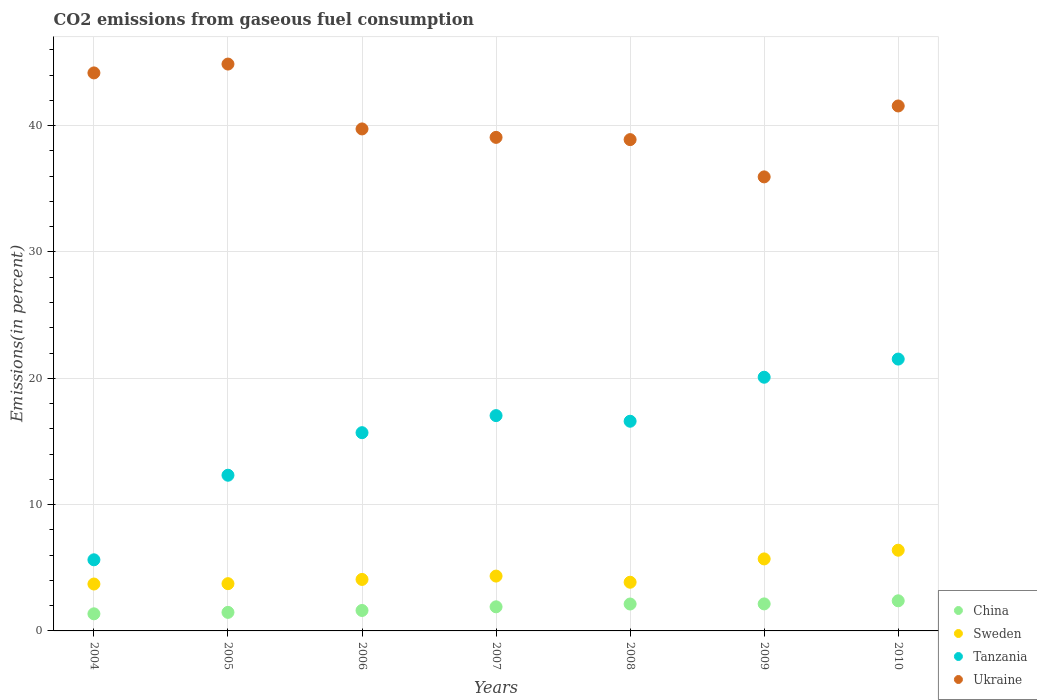Is the number of dotlines equal to the number of legend labels?
Offer a terse response. Yes. What is the total CO2 emitted in Tanzania in 2008?
Your response must be concise. 16.6. Across all years, what is the maximum total CO2 emitted in Tanzania?
Your response must be concise. 21.52. Across all years, what is the minimum total CO2 emitted in Ukraine?
Keep it short and to the point. 35.94. In which year was the total CO2 emitted in Tanzania minimum?
Your response must be concise. 2004. What is the total total CO2 emitted in Tanzania in the graph?
Keep it short and to the point. 108.9. What is the difference between the total CO2 emitted in Tanzania in 2004 and that in 2008?
Your response must be concise. -10.97. What is the difference between the total CO2 emitted in Sweden in 2005 and the total CO2 emitted in Tanzania in 2009?
Offer a very short reply. -16.34. What is the average total CO2 emitted in Sweden per year?
Keep it short and to the point. 4.54. In the year 2007, what is the difference between the total CO2 emitted in Tanzania and total CO2 emitted in China?
Your answer should be very brief. 15.14. What is the ratio of the total CO2 emitted in Tanzania in 2006 to that in 2009?
Give a very brief answer. 0.78. Is the total CO2 emitted in Sweden in 2005 less than that in 2010?
Your response must be concise. Yes. Is the difference between the total CO2 emitted in Tanzania in 2007 and 2010 greater than the difference between the total CO2 emitted in China in 2007 and 2010?
Give a very brief answer. No. What is the difference between the highest and the second highest total CO2 emitted in Ukraine?
Your answer should be very brief. 0.7. What is the difference between the highest and the lowest total CO2 emitted in Tanzania?
Make the answer very short. 15.89. Is it the case that in every year, the sum of the total CO2 emitted in Ukraine and total CO2 emitted in Sweden  is greater than the sum of total CO2 emitted in Tanzania and total CO2 emitted in China?
Offer a very short reply. Yes. Is the total CO2 emitted in Sweden strictly greater than the total CO2 emitted in China over the years?
Keep it short and to the point. Yes. How many dotlines are there?
Your answer should be compact. 4. Are the values on the major ticks of Y-axis written in scientific E-notation?
Ensure brevity in your answer.  No. Does the graph contain any zero values?
Offer a very short reply. No. Where does the legend appear in the graph?
Your answer should be compact. Bottom right. What is the title of the graph?
Your answer should be very brief. CO2 emissions from gaseous fuel consumption. What is the label or title of the Y-axis?
Ensure brevity in your answer.  Emissions(in percent). What is the Emissions(in percent) in China in 2004?
Offer a terse response. 1.35. What is the Emissions(in percent) of Sweden in 2004?
Your answer should be very brief. 3.71. What is the Emissions(in percent) of Tanzania in 2004?
Your answer should be very brief. 5.63. What is the Emissions(in percent) of Ukraine in 2004?
Keep it short and to the point. 44.17. What is the Emissions(in percent) in China in 2005?
Offer a terse response. 1.47. What is the Emissions(in percent) in Sweden in 2005?
Your answer should be very brief. 3.74. What is the Emissions(in percent) in Tanzania in 2005?
Make the answer very short. 12.33. What is the Emissions(in percent) in Ukraine in 2005?
Offer a very short reply. 44.87. What is the Emissions(in percent) in China in 2006?
Your answer should be very brief. 1.62. What is the Emissions(in percent) in Sweden in 2006?
Ensure brevity in your answer.  4.08. What is the Emissions(in percent) of Tanzania in 2006?
Keep it short and to the point. 15.69. What is the Emissions(in percent) in Ukraine in 2006?
Offer a terse response. 39.74. What is the Emissions(in percent) in China in 2007?
Ensure brevity in your answer.  1.91. What is the Emissions(in percent) of Sweden in 2007?
Ensure brevity in your answer.  4.34. What is the Emissions(in percent) in Tanzania in 2007?
Your response must be concise. 17.04. What is the Emissions(in percent) in Ukraine in 2007?
Provide a short and direct response. 39.07. What is the Emissions(in percent) in China in 2008?
Your response must be concise. 2.13. What is the Emissions(in percent) in Sweden in 2008?
Give a very brief answer. 3.85. What is the Emissions(in percent) in Tanzania in 2008?
Provide a short and direct response. 16.6. What is the Emissions(in percent) in Ukraine in 2008?
Provide a short and direct response. 38.89. What is the Emissions(in percent) of China in 2009?
Offer a very short reply. 2.14. What is the Emissions(in percent) of Sweden in 2009?
Your answer should be very brief. 5.7. What is the Emissions(in percent) of Tanzania in 2009?
Make the answer very short. 20.08. What is the Emissions(in percent) of Ukraine in 2009?
Your answer should be very brief. 35.94. What is the Emissions(in percent) of China in 2010?
Keep it short and to the point. 2.38. What is the Emissions(in percent) in Sweden in 2010?
Keep it short and to the point. 6.39. What is the Emissions(in percent) in Tanzania in 2010?
Give a very brief answer. 21.52. What is the Emissions(in percent) of Ukraine in 2010?
Offer a very short reply. 41.56. Across all years, what is the maximum Emissions(in percent) of China?
Give a very brief answer. 2.38. Across all years, what is the maximum Emissions(in percent) of Sweden?
Your answer should be very brief. 6.39. Across all years, what is the maximum Emissions(in percent) of Tanzania?
Provide a short and direct response. 21.52. Across all years, what is the maximum Emissions(in percent) of Ukraine?
Make the answer very short. 44.87. Across all years, what is the minimum Emissions(in percent) of China?
Your answer should be very brief. 1.35. Across all years, what is the minimum Emissions(in percent) in Sweden?
Your answer should be compact. 3.71. Across all years, what is the minimum Emissions(in percent) of Tanzania?
Provide a succinct answer. 5.63. Across all years, what is the minimum Emissions(in percent) of Ukraine?
Your answer should be compact. 35.94. What is the total Emissions(in percent) in China in the graph?
Offer a very short reply. 13. What is the total Emissions(in percent) of Sweden in the graph?
Your answer should be compact. 31.81. What is the total Emissions(in percent) of Tanzania in the graph?
Offer a very short reply. 108.9. What is the total Emissions(in percent) of Ukraine in the graph?
Give a very brief answer. 284.25. What is the difference between the Emissions(in percent) in China in 2004 and that in 2005?
Your answer should be compact. -0.11. What is the difference between the Emissions(in percent) in Sweden in 2004 and that in 2005?
Ensure brevity in your answer.  -0.03. What is the difference between the Emissions(in percent) in Tanzania in 2004 and that in 2005?
Keep it short and to the point. -6.69. What is the difference between the Emissions(in percent) in Ukraine in 2004 and that in 2005?
Keep it short and to the point. -0.7. What is the difference between the Emissions(in percent) of China in 2004 and that in 2006?
Your answer should be very brief. -0.27. What is the difference between the Emissions(in percent) in Sweden in 2004 and that in 2006?
Ensure brevity in your answer.  -0.36. What is the difference between the Emissions(in percent) in Tanzania in 2004 and that in 2006?
Make the answer very short. -10.06. What is the difference between the Emissions(in percent) of Ukraine in 2004 and that in 2006?
Your response must be concise. 4.43. What is the difference between the Emissions(in percent) of China in 2004 and that in 2007?
Give a very brief answer. -0.55. What is the difference between the Emissions(in percent) in Sweden in 2004 and that in 2007?
Your answer should be very brief. -0.63. What is the difference between the Emissions(in percent) in Tanzania in 2004 and that in 2007?
Offer a terse response. -11.41. What is the difference between the Emissions(in percent) of Ukraine in 2004 and that in 2007?
Offer a very short reply. 5.1. What is the difference between the Emissions(in percent) of China in 2004 and that in 2008?
Keep it short and to the point. -0.78. What is the difference between the Emissions(in percent) in Sweden in 2004 and that in 2008?
Your answer should be compact. -0.14. What is the difference between the Emissions(in percent) of Tanzania in 2004 and that in 2008?
Provide a short and direct response. -10.97. What is the difference between the Emissions(in percent) of Ukraine in 2004 and that in 2008?
Offer a terse response. 5.28. What is the difference between the Emissions(in percent) of China in 2004 and that in 2009?
Provide a succinct answer. -0.79. What is the difference between the Emissions(in percent) in Sweden in 2004 and that in 2009?
Ensure brevity in your answer.  -1.99. What is the difference between the Emissions(in percent) in Tanzania in 2004 and that in 2009?
Offer a terse response. -14.45. What is the difference between the Emissions(in percent) of Ukraine in 2004 and that in 2009?
Make the answer very short. 8.23. What is the difference between the Emissions(in percent) of China in 2004 and that in 2010?
Offer a very short reply. -1.03. What is the difference between the Emissions(in percent) in Sweden in 2004 and that in 2010?
Give a very brief answer. -2.68. What is the difference between the Emissions(in percent) in Tanzania in 2004 and that in 2010?
Make the answer very short. -15.89. What is the difference between the Emissions(in percent) in Ukraine in 2004 and that in 2010?
Your response must be concise. 2.62. What is the difference between the Emissions(in percent) in China in 2005 and that in 2006?
Keep it short and to the point. -0.15. What is the difference between the Emissions(in percent) in Sweden in 2005 and that in 2006?
Give a very brief answer. -0.34. What is the difference between the Emissions(in percent) in Tanzania in 2005 and that in 2006?
Offer a very short reply. -3.37. What is the difference between the Emissions(in percent) in Ukraine in 2005 and that in 2006?
Give a very brief answer. 5.14. What is the difference between the Emissions(in percent) of China in 2005 and that in 2007?
Give a very brief answer. -0.44. What is the difference between the Emissions(in percent) of Sweden in 2005 and that in 2007?
Offer a terse response. -0.6. What is the difference between the Emissions(in percent) in Tanzania in 2005 and that in 2007?
Provide a succinct answer. -4.72. What is the difference between the Emissions(in percent) in Ukraine in 2005 and that in 2007?
Offer a very short reply. 5.8. What is the difference between the Emissions(in percent) in China in 2005 and that in 2008?
Make the answer very short. -0.66. What is the difference between the Emissions(in percent) of Sweden in 2005 and that in 2008?
Give a very brief answer. -0.11. What is the difference between the Emissions(in percent) in Tanzania in 2005 and that in 2008?
Your answer should be compact. -4.27. What is the difference between the Emissions(in percent) of Ukraine in 2005 and that in 2008?
Keep it short and to the point. 5.98. What is the difference between the Emissions(in percent) of China in 2005 and that in 2009?
Make the answer very short. -0.67. What is the difference between the Emissions(in percent) in Sweden in 2005 and that in 2009?
Your response must be concise. -1.96. What is the difference between the Emissions(in percent) in Tanzania in 2005 and that in 2009?
Keep it short and to the point. -7.76. What is the difference between the Emissions(in percent) of Ukraine in 2005 and that in 2009?
Offer a terse response. 8.93. What is the difference between the Emissions(in percent) in China in 2005 and that in 2010?
Keep it short and to the point. -0.92. What is the difference between the Emissions(in percent) in Sweden in 2005 and that in 2010?
Your answer should be compact. -2.65. What is the difference between the Emissions(in percent) in Tanzania in 2005 and that in 2010?
Offer a terse response. -9.2. What is the difference between the Emissions(in percent) in Ukraine in 2005 and that in 2010?
Offer a very short reply. 3.32. What is the difference between the Emissions(in percent) of China in 2006 and that in 2007?
Ensure brevity in your answer.  -0.29. What is the difference between the Emissions(in percent) in Sweden in 2006 and that in 2007?
Give a very brief answer. -0.27. What is the difference between the Emissions(in percent) of Tanzania in 2006 and that in 2007?
Give a very brief answer. -1.35. What is the difference between the Emissions(in percent) in Ukraine in 2006 and that in 2007?
Offer a very short reply. 0.67. What is the difference between the Emissions(in percent) of China in 2006 and that in 2008?
Your answer should be compact. -0.51. What is the difference between the Emissions(in percent) in Sweden in 2006 and that in 2008?
Your answer should be compact. 0.22. What is the difference between the Emissions(in percent) of Tanzania in 2006 and that in 2008?
Your answer should be compact. -0.91. What is the difference between the Emissions(in percent) in Ukraine in 2006 and that in 2008?
Offer a very short reply. 0.85. What is the difference between the Emissions(in percent) of China in 2006 and that in 2009?
Provide a short and direct response. -0.52. What is the difference between the Emissions(in percent) of Sweden in 2006 and that in 2009?
Give a very brief answer. -1.62. What is the difference between the Emissions(in percent) of Tanzania in 2006 and that in 2009?
Your answer should be compact. -4.39. What is the difference between the Emissions(in percent) in Ukraine in 2006 and that in 2009?
Your response must be concise. 3.8. What is the difference between the Emissions(in percent) in China in 2006 and that in 2010?
Your answer should be compact. -0.77. What is the difference between the Emissions(in percent) in Sweden in 2006 and that in 2010?
Keep it short and to the point. -2.31. What is the difference between the Emissions(in percent) in Tanzania in 2006 and that in 2010?
Offer a terse response. -5.83. What is the difference between the Emissions(in percent) of Ukraine in 2006 and that in 2010?
Offer a terse response. -1.82. What is the difference between the Emissions(in percent) in China in 2007 and that in 2008?
Provide a short and direct response. -0.22. What is the difference between the Emissions(in percent) of Sweden in 2007 and that in 2008?
Provide a short and direct response. 0.49. What is the difference between the Emissions(in percent) in Tanzania in 2007 and that in 2008?
Offer a very short reply. 0.45. What is the difference between the Emissions(in percent) in Ukraine in 2007 and that in 2008?
Your answer should be compact. 0.18. What is the difference between the Emissions(in percent) of China in 2007 and that in 2009?
Offer a very short reply. -0.23. What is the difference between the Emissions(in percent) of Sweden in 2007 and that in 2009?
Give a very brief answer. -1.36. What is the difference between the Emissions(in percent) of Tanzania in 2007 and that in 2009?
Your answer should be compact. -3.04. What is the difference between the Emissions(in percent) in Ukraine in 2007 and that in 2009?
Offer a terse response. 3.13. What is the difference between the Emissions(in percent) in China in 2007 and that in 2010?
Your answer should be very brief. -0.48. What is the difference between the Emissions(in percent) of Sweden in 2007 and that in 2010?
Provide a succinct answer. -2.05. What is the difference between the Emissions(in percent) in Tanzania in 2007 and that in 2010?
Your answer should be very brief. -4.48. What is the difference between the Emissions(in percent) in Ukraine in 2007 and that in 2010?
Give a very brief answer. -2.49. What is the difference between the Emissions(in percent) in China in 2008 and that in 2009?
Provide a succinct answer. -0.01. What is the difference between the Emissions(in percent) in Sweden in 2008 and that in 2009?
Offer a very short reply. -1.85. What is the difference between the Emissions(in percent) of Tanzania in 2008 and that in 2009?
Make the answer very short. -3.48. What is the difference between the Emissions(in percent) in Ukraine in 2008 and that in 2009?
Give a very brief answer. 2.95. What is the difference between the Emissions(in percent) in China in 2008 and that in 2010?
Keep it short and to the point. -0.25. What is the difference between the Emissions(in percent) of Sweden in 2008 and that in 2010?
Your response must be concise. -2.54. What is the difference between the Emissions(in percent) in Tanzania in 2008 and that in 2010?
Offer a terse response. -4.92. What is the difference between the Emissions(in percent) in Ukraine in 2008 and that in 2010?
Your answer should be compact. -2.66. What is the difference between the Emissions(in percent) of China in 2009 and that in 2010?
Your answer should be very brief. -0.24. What is the difference between the Emissions(in percent) in Sweden in 2009 and that in 2010?
Ensure brevity in your answer.  -0.69. What is the difference between the Emissions(in percent) in Tanzania in 2009 and that in 2010?
Offer a very short reply. -1.44. What is the difference between the Emissions(in percent) in Ukraine in 2009 and that in 2010?
Your answer should be compact. -5.61. What is the difference between the Emissions(in percent) of China in 2004 and the Emissions(in percent) of Sweden in 2005?
Provide a succinct answer. -2.39. What is the difference between the Emissions(in percent) in China in 2004 and the Emissions(in percent) in Tanzania in 2005?
Provide a short and direct response. -10.97. What is the difference between the Emissions(in percent) in China in 2004 and the Emissions(in percent) in Ukraine in 2005?
Your answer should be compact. -43.52. What is the difference between the Emissions(in percent) in Sweden in 2004 and the Emissions(in percent) in Tanzania in 2005?
Your answer should be compact. -8.61. What is the difference between the Emissions(in percent) in Sweden in 2004 and the Emissions(in percent) in Ukraine in 2005?
Keep it short and to the point. -41.16. What is the difference between the Emissions(in percent) in Tanzania in 2004 and the Emissions(in percent) in Ukraine in 2005?
Your answer should be compact. -39.24. What is the difference between the Emissions(in percent) of China in 2004 and the Emissions(in percent) of Sweden in 2006?
Keep it short and to the point. -2.72. What is the difference between the Emissions(in percent) in China in 2004 and the Emissions(in percent) in Tanzania in 2006?
Ensure brevity in your answer.  -14.34. What is the difference between the Emissions(in percent) of China in 2004 and the Emissions(in percent) of Ukraine in 2006?
Provide a succinct answer. -38.39. What is the difference between the Emissions(in percent) in Sweden in 2004 and the Emissions(in percent) in Tanzania in 2006?
Make the answer very short. -11.98. What is the difference between the Emissions(in percent) in Sweden in 2004 and the Emissions(in percent) in Ukraine in 2006?
Your response must be concise. -36.03. What is the difference between the Emissions(in percent) in Tanzania in 2004 and the Emissions(in percent) in Ukraine in 2006?
Your answer should be very brief. -34.11. What is the difference between the Emissions(in percent) of China in 2004 and the Emissions(in percent) of Sweden in 2007?
Your response must be concise. -2.99. What is the difference between the Emissions(in percent) in China in 2004 and the Emissions(in percent) in Tanzania in 2007?
Offer a terse response. -15.69. What is the difference between the Emissions(in percent) in China in 2004 and the Emissions(in percent) in Ukraine in 2007?
Provide a short and direct response. -37.72. What is the difference between the Emissions(in percent) of Sweden in 2004 and the Emissions(in percent) of Tanzania in 2007?
Provide a succinct answer. -13.33. What is the difference between the Emissions(in percent) of Sweden in 2004 and the Emissions(in percent) of Ukraine in 2007?
Give a very brief answer. -35.36. What is the difference between the Emissions(in percent) in Tanzania in 2004 and the Emissions(in percent) in Ukraine in 2007?
Provide a succinct answer. -33.44. What is the difference between the Emissions(in percent) of China in 2004 and the Emissions(in percent) of Sweden in 2008?
Offer a very short reply. -2.5. What is the difference between the Emissions(in percent) of China in 2004 and the Emissions(in percent) of Tanzania in 2008?
Offer a terse response. -15.25. What is the difference between the Emissions(in percent) of China in 2004 and the Emissions(in percent) of Ukraine in 2008?
Your answer should be very brief. -37.54. What is the difference between the Emissions(in percent) in Sweden in 2004 and the Emissions(in percent) in Tanzania in 2008?
Offer a very short reply. -12.89. What is the difference between the Emissions(in percent) in Sweden in 2004 and the Emissions(in percent) in Ukraine in 2008?
Your response must be concise. -35.18. What is the difference between the Emissions(in percent) of Tanzania in 2004 and the Emissions(in percent) of Ukraine in 2008?
Your answer should be compact. -33.26. What is the difference between the Emissions(in percent) in China in 2004 and the Emissions(in percent) in Sweden in 2009?
Your response must be concise. -4.35. What is the difference between the Emissions(in percent) in China in 2004 and the Emissions(in percent) in Tanzania in 2009?
Offer a very short reply. -18.73. What is the difference between the Emissions(in percent) in China in 2004 and the Emissions(in percent) in Ukraine in 2009?
Your answer should be compact. -34.59. What is the difference between the Emissions(in percent) of Sweden in 2004 and the Emissions(in percent) of Tanzania in 2009?
Give a very brief answer. -16.37. What is the difference between the Emissions(in percent) in Sweden in 2004 and the Emissions(in percent) in Ukraine in 2009?
Offer a terse response. -32.23. What is the difference between the Emissions(in percent) in Tanzania in 2004 and the Emissions(in percent) in Ukraine in 2009?
Provide a short and direct response. -30.31. What is the difference between the Emissions(in percent) in China in 2004 and the Emissions(in percent) in Sweden in 2010?
Keep it short and to the point. -5.04. What is the difference between the Emissions(in percent) in China in 2004 and the Emissions(in percent) in Tanzania in 2010?
Offer a very short reply. -20.17. What is the difference between the Emissions(in percent) in China in 2004 and the Emissions(in percent) in Ukraine in 2010?
Keep it short and to the point. -40.2. What is the difference between the Emissions(in percent) of Sweden in 2004 and the Emissions(in percent) of Tanzania in 2010?
Keep it short and to the point. -17.81. What is the difference between the Emissions(in percent) in Sweden in 2004 and the Emissions(in percent) in Ukraine in 2010?
Your answer should be very brief. -37.84. What is the difference between the Emissions(in percent) in Tanzania in 2004 and the Emissions(in percent) in Ukraine in 2010?
Offer a very short reply. -35.93. What is the difference between the Emissions(in percent) in China in 2005 and the Emissions(in percent) in Sweden in 2006?
Ensure brevity in your answer.  -2.61. What is the difference between the Emissions(in percent) in China in 2005 and the Emissions(in percent) in Tanzania in 2006?
Offer a very short reply. -14.22. What is the difference between the Emissions(in percent) in China in 2005 and the Emissions(in percent) in Ukraine in 2006?
Provide a short and direct response. -38.27. What is the difference between the Emissions(in percent) of Sweden in 2005 and the Emissions(in percent) of Tanzania in 2006?
Your response must be concise. -11.95. What is the difference between the Emissions(in percent) of Sweden in 2005 and the Emissions(in percent) of Ukraine in 2006?
Ensure brevity in your answer.  -36. What is the difference between the Emissions(in percent) in Tanzania in 2005 and the Emissions(in percent) in Ukraine in 2006?
Provide a short and direct response. -27.41. What is the difference between the Emissions(in percent) in China in 2005 and the Emissions(in percent) in Sweden in 2007?
Your response must be concise. -2.87. What is the difference between the Emissions(in percent) of China in 2005 and the Emissions(in percent) of Tanzania in 2007?
Your response must be concise. -15.58. What is the difference between the Emissions(in percent) in China in 2005 and the Emissions(in percent) in Ukraine in 2007?
Your response must be concise. -37.6. What is the difference between the Emissions(in percent) of Sweden in 2005 and the Emissions(in percent) of Tanzania in 2007?
Offer a terse response. -13.3. What is the difference between the Emissions(in percent) of Sweden in 2005 and the Emissions(in percent) of Ukraine in 2007?
Your answer should be compact. -35.33. What is the difference between the Emissions(in percent) in Tanzania in 2005 and the Emissions(in percent) in Ukraine in 2007?
Give a very brief answer. -26.75. What is the difference between the Emissions(in percent) of China in 2005 and the Emissions(in percent) of Sweden in 2008?
Your answer should be compact. -2.38. What is the difference between the Emissions(in percent) in China in 2005 and the Emissions(in percent) in Tanzania in 2008?
Your answer should be very brief. -15.13. What is the difference between the Emissions(in percent) of China in 2005 and the Emissions(in percent) of Ukraine in 2008?
Keep it short and to the point. -37.42. What is the difference between the Emissions(in percent) of Sweden in 2005 and the Emissions(in percent) of Tanzania in 2008?
Provide a succinct answer. -12.86. What is the difference between the Emissions(in percent) of Sweden in 2005 and the Emissions(in percent) of Ukraine in 2008?
Offer a terse response. -35.15. What is the difference between the Emissions(in percent) in Tanzania in 2005 and the Emissions(in percent) in Ukraine in 2008?
Provide a short and direct response. -26.57. What is the difference between the Emissions(in percent) of China in 2005 and the Emissions(in percent) of Sweden in 2009?
Provide a succinct answer. -4.23. What is the difference between the Emissions(in percent) in China in 2005 and the Emissions(in percent) in Tanzania in 2009?
Provide a short and direct response. -18.61. What is the difference between the Emissions(in percent) in China in 2005 and the Emissions(in percent) in Ukraine in 2009?
Your answer should be very brief. -34.47. What is the difference between the Emissions(in percent) in Sweden in 2005 and the Emissions(in percent) in Tanzania in 2009?
Ensure brevity in your answer.  -16.34. What is the difference between the Emissions(in percent) of Sweden in 2005 and the Emissions(in percent) of Ukraine in 2009?
Your response must be concise. -32.2. What is the difference between the Emissions(in percent) in Tanzania in 2005 and the Emissions(in percent) in Ukraine in 2009?
Your answer should be very brief. -23.62. What is the difference between the Emissions(in percent) of China in 2005 and the Emissions(in percent) of Sweden in 2010?
Your response must be concise. -4.92. What is the difference between the Emissions(in percent) in China in 2005 and the Emissions(in percent) in Tanzania in 2010?
Offer a very short reply. -20.05. What is the difference between the Emissions(in percent) of China in 2005 and the Emissions(in percent) of Ukraine in 2010?
Offer a very short reply. -40.09. What is the difference between the Emissions(in percent) in Sweden in 2005 and the Emissions(in percent) in Tanzania in 2010?
Ensure brevity in your answer.  -17.78. What is the difference between the Emissions(in percent) in Sweden in 2005 and the Emissions(in percent) in Ukraine in 2010?
Offer a very short reply. -37.82. What is the difference between the Emissions(in percent) in Tanzania in 2005 and the Emissions(in percent) in Ukraine in 2010?
Offer a very short reply. -29.23. What is the difference between the Emissions(in percent) of China in 2006 and the Emissions(in percent) of Sweden in 2007?
Offer a very short reply. -2.72. What is the difference between the Emissions(in percent) in China in 2006 and the Emissions(in percent) in Tanzania in 2007?
Make the answer very short. -15.43. What is the difference between the Emissions(in percent) in China in 2006 and the Emissions(in percent) in Ukraine in 2007?
Offer a very short reply. -37.45. What is the difference between the Emissions(in percent) in Sweden in 2006 and the Emissions(in percent) in Tanzania in 2007?
Your answer should be compact. -12.97. What is the difference between the Emissions(in percent) in Sweden in 2006 and the Emissions(in percent) in Ukraine in 2007?
Make the answer very short. -35. What is the difference between the Emissions(in percent) of Tanzania in 2006 and the Emissions(in percent) of Ukraine in 2007?
Provide a succinct answer. -23.38. What is the difference between the Emissions(in percent) of China in 2006 and the Emissions(in percent) of Sweden in 2008?
Make the answer very short. -2.23. What is the difference between the Emissions(in percent) in China in 2006 and the Emissions(in percent) in Tanzania in 2008?
Provide a short and direct response. -14.98. What is the difference between the Emissions(in percent) of China in 2006 and the Emissions(in percent) of Ukraine in 2008?
Give a very brief answer. -37.27. What is the difference between the Emissions(in percent) of Sweden in 2006 and the Emissions(in percent) of Tanzania in 2008?
Your response must be concise. -12.52. What is the difference between the Emissions(in percent) of Sweden in 2006 and the Emissions(in percent) of Ukraine in 2008?
Keep it short and to the point. -34.82. What is the difference between the Emissions(in percent) in Tanzania in 2006 and the Emissions(in percent) in Ukraine in 2008?
Provide a short and direct response. -23.2. What is the difference between the Emissions(in percent) in China in 2006 and the Emissions(in percent) in Sweden in 2009?
Provide a short and direct response. -4.08. What is the difference between the Emissions(in percent) in China in 2006 and the Emissions(in percent) in Tanzania in 2009?
Provide a short and direct response. -18.46. What is the difference between the Emissions(in percent) in China in 2006 and the Emissions(in percent) in Ukraine in 2009?
Give a very brief answer. -34.32. What is the difference between the Emissions(in percent) in Sweden in 2006 and the Emissions(in percent) in Tanzania in 2009?
Provide a short and direct response. -16.01. What is the difference between the Emissions(in percent) of Sweden in 2006 and the Emissions(in percent) of Ukraine in 2009?
Your answer should be very brief. -31.87. What is the difference between the Emissions(in percent) of Tanzania in 2006 and the Emissions(in percent) of Ukraine in 2009?
Offer a terse response. -20.25. What is the difference between the Emissions(in percent) of China in 2006 and the Emissions(in percent) of Sweden in 2010?
Your answer should be compact. -4.77. What is the difference between the Emissions(in percent) of China in 2006 and the Emissions(in percent) of Tanzania in 2010?
Provide a succinct answer. -19.9. What is the difference between the Emissions(in percent) in China in 2006 and the Emissions(in percent) in Ukraine in 2010?
Provide a succinct answer. -39.94. What is the difference between the Emissions(in percent) of Sweden in 2006 and the Emissions(in percent) of Tanzania in 2010?
Provide a short and direct response. -17.44. What is the difference between the Emissions(in percent) of Sweden in 2006 and the Emissions(in percent) of Ukraine in 2010?
Offer a terse response. -37.48. What is the difference between the Emissions(in percent) in Tanzania in 2006 and the Emissions(in percent) in Ukraine in 2010?
Provide a succinct answer. -25.86. What is the difference between the Emissions(in percent) in China in 2007 and the Emissions(in percent) in Sweden in 2008?
Provide a succinct answer. -1.95. What is the difference between the Emissions(in percent) in China in 2007 and the Emissions(in percent) in Tanzania in 2008?
Keep it short and to the point. -14.69. What is the difference between the Emissions(in percent) in China in 2007 and the Emissions(in percent) in Ukraine in 2008?
Your answer should be compact. -36.99. What is the difference between the Emissions(in percent) of Sweden in 2007 and the Emissions(in percent) of Tanzania in 2008?
Offer a very short reply. -12.26. What is the difference between the Emissions(in percent) in Sweden in 2007 and the Emissions(in percent) in Ukraine in 2008?
Give a very brief answer. -34.55. What is the difference between the Emissions(in percent) of Tanzania in 2007 and the Emissions(in percent) of Ukraine in 2008?
Ensure brevity in your answer.  -21.85. What is the difference between the Emissions(in percent) of China in 2007 and the Emissions(in percent) of Sweden in 2009?
Keep it short and to the point. -3.79. What is the difference between the Emissions(in percent) of China in 2007 and the Emissions(in percent) of Tanzania in 2009?
Your answer should be very brief. -18.18. What is the difference between the Emissions(in percent) in China in 2007 and the Emissions(in percent) in Ukraine in 2009?
Ensure brevity in your answer.  -34.04. What is the difference between the Emissions(in percent) of Sweden in 2007 and the Emissions(in percent) of Tanzania in 2009?
Ensure brevity in your answer.  -15.74. What is the difference between the Emissions(in percent) of Sweden in 2007 and the Emissions(in percent) of Ukraine in 2009?
Your answer should be very brief. -31.6. What is the difference between the Emissions(in percent) in Tanzania in 2007 and the Emissions(in percent) in Ukraine in 2009?
Offer a very short reply. -18.9. What is the difference between the Emissions(in percent) of China in 2007 and the Emissions(in percent) of Sweden in 2010?
Give a very brief answer. -4.48. What is the difference between the Emissions(in percent) in China in 2007 and the Emissions(in percent) in Tanzania in 2010?
Make the answer very short. -19.61. What is the difference between the Emissions(in percent) of China in 2007 and the Emissions(in percent) of Ukraine in 2010?
Ensure brevity in your answer.  -39.65. What is the difference between the Emissions(in percent) in Sweden in 2007 and the Emissions(in percent) in Tanzania in 2010?
Your response must be concise. -17.18. What is the difference between the Emissions(in percent) in Sweden in 2007 and the Emissions(in percent) in Ukraine in 2010?
Provide a short and direct response. -37.22. What is the difference between the Emissions(in percent) of Tanzania in 2007 and the Emissions(in percent) of Ukraine in 2010?
Provide a succinct answer. -24.51. What is the difference between the Emissions(in percent) in China in 2008 and the Emissions(in percent) in Sweden in 2009?
Provide a short and direct response. -3.57. What is the difference between the Emissions(in percent) in China in 2008 and the Emissions(in percent) in Tanzania in 2009?
Ensure brevity in your answer.  -17.95. What is the difference between the Emissions(in percent) of China in 2008 and the Emissions(in percent) of Ukraine in 2009?
Your answer should be very brief. -33.81. What is the difference between the Emissions(in percent) in Sweden in 2008 and the Emissions(in percent) in Tanzania in 2009?
Make the answer very short. -16.23. What is the difference between the Emissions(in percent) of Sweden in 2008 and the Emissions(in percent) of Ukraine in 2009?
Make the answer very short. -32.09. What is the difference between the Emissions(in percent) in Tanzania in 2008 and the Emissions(in percent) in Ukraine in 2009?
Make the answer very short. -19.34. What is the difference between the Emissions(in percent) of China in 2008 and the Emissions(in percent) of Sweden in 2010?
Your answer should be compact. -4.26. What is the difference between the Emissions(in percent) of China in 2008 and the Emissions(in percent) of Tanzania in 2010?
Offer a terse response. -19.39. What is the difference between the Emissions(in percent) in China in 2008 and the Emissions(in percent) in Ukraine in 2010?
Make the answer very short. -39.43. What is the difference between the Emissions(in percent) in Sweden in 2008 and the Emissions(in percent) in Tanzania in 2010?
Keep it short and to the point. -17.67. What is the difference between the Emissions(in percent) in Sweden in 2008 and the Emissions(in percent) in Ukraine in 2010?
Provide a short and direct response. -37.7. What is the difference between the Emissions(in percent) of Tanzania in 2008 and the Emissions(in percent) of Ukraine in 2010?
Make the answer very short. -24.96. What is the difference between the Emissions(in percent) in China in 2009 and the Emissions(in percent) in Sweden in 2010?
Your answer should be very brief. -4.25. What is the difference between the Emissions(in percent) in China in 2009 and the Emissions(in percent) in Tanzania in 2010?
Offer a terse response. -19.38. What is the difference between the Emissions(in percent) in China in 2009 and the Emissions(in percent) in Ukraine in 2010?
Keep it short and to the point. -39.42. What is the difference between the Emissions(in percent) of Sweden in 2009 and the Emissions(in percent) of Tanzania in 2010?
Make the answer very short. -15.82. What is the difference between the Emissions(in percent) in Sweden in 2009 and the Emissions(in percent) in Ukraine in 2010?
Give a very brief answer. -35.86. What is the difference between the Emissions(in percent) in Tanzania in 2009 and the Emissions(in percent) in Ukraine in 2010?
Provide a short and direct response. -21.47. What is the average Emissions(in percent) of China per year?
Make the answer very short. 1.86. What is the average Emissions(in percent) of Sweden per year?
Your answer should be very brief. 4.54. What is the average Emissions(in percent) in Tanzania per year?
Make the answer very short. 15.56. What is the average Emissions(in percent) of Ukraine per year?
Your answer should be compact. 40.61. In the year 2004, what is the difference between the Emissions(in percent) in China and Emissions(in percent) in Sweden?
Give a very brief answer. -2.36. In the year 2004, what is the difference between the Emissions(in percent) of China and Emissions(in percent) of Tanzania?
Ensure brevity in your answer.  -4.28. In the year 2004, what is the difference between the Emissions(in percent) of China and Emissions(in percent) of Ukraine?
Make the answer very short. -42.82. In the year 2004, what is the difference between the Emissions(in percent) in Sweden and Emissions(in percent) in Tanzania?
Your answer should be very brief. -1.92. In the year 2004, what is the difference between the Emissions(in percent) in Sweden and Emissions(in percent) in Ukraine?
Provide a succinct answer. -40.46. In the year 2004, what is the difference between the Emissions(in percent) in Tanzania and Emissions(in percent) in Ukraine?
Your answer should be compact. -38.54. In the year 2005, what is the difference between the Emissions(in percent) in China and Emissions(in percent) in Sweden?
Your answer should be compact. -2.27. In the year 2005, what is the difference between the Emissions(in percent) in China and Emissions(in percent) in Tanzania?
Provide a short and direct response. -10.86. In the year 2005, what is the difference between the Emissions(in percent) of China and Emissions(in percent) of Ukraine?
Provide a short and direct response. -43.41. In the year 2005, what is the difference between the Emissions(in percent) of Sweden and Emissions(in percent) of Tanzania?
Give a very brief answer. -8.58. In the year 2005, what is the difference between the Emissions(in percent) of Sweden and Emissions(in percent) of Ukraine?
Provide a succinct answer. -41.13. In the year 2005, what is the difference between the Emissions(in percent) in Tanzania and Emissions(in percent) in Ukraine?
Make the answer very short. -32.55. In the year 2006, what is the difference between the Emissions(in percent) in China and Emissions(in percent) in Sweden?
Make the answer very short. -2.46. In the year 2006, what is the difference between the Emissions(in percent) of China and Emissions(in percent) of Tanzania?
Provide a short and direct response. -14.07. In the year 2006, what is the difference between the Emissions(in percent) in China and Emissions(in percent) in Ukraine?
Your answer should be compact. -38.12. In the year 2006, what is the difference between the Emissions(in percent) of Sweden and Emissions(in percent) of Tanzania?
Provide a succinct answer. -11.62. In the year 2006, what is the difference between the Emissions(in percent) in Sweden and Emissions(in percent) in Ukraine?
Keep it short and to the point. -35.66. In the year 2006, what is the difference between the Emissions(in percent) of Tanzania and Emissions(in percent) of Ukraine?
Your answer should be very brief. -24.05. In the year 2007, what is the difference between the Emissions(in percent) of China and Emissions(in percent) of Sweden?
Provide a short and direct response. -2.43. In the year 2007, what is the difference between the Emissions(in percent) in China and Emissions(in percent) in Tanzania?
Your answer should be very brief. -15.14. In the year 2007, what is the difference between the Emissions(in percent) in China and Emissions(in percent) in Ukraine?
Your response must be concise. -37.16. In the year 2007, what is the difference between the Emissions(in percent) in Sweden and Emissions(in percent) in Tanzania?
Offer a terse response. -12.7. In the year 2007, what is the difference between the Emissions(in percent) of Sweden and Emissions(in percent) of Ukraine?
Your answer should be very brief. -34.73. In the year 2007, what is the difference between the Emissions(in percent) of Tanzania and Emissions(in percent) of Ukraine?
Give a very brief answer. -22.03. In the year 2008, what is the difference between the Emissions(in percent) of China and Emissions(in percent) of Sweden?
Provide a succinct answer. -1.72. In the year 2008, what is the difference between the Emissions(in percent) of China and Emissions(in percent) of Tanzania?
Keep it short and to the point. -14.47. In the year 2008, what is the difference between the Emissions(in percent) in China and Emissions(in percent) in Ukraine?
Your answer should be compact. -36.76. In the year 2008, what is the difference between the Emissions(in percent) in Sweden and Emissions(in percent) in Tanzania?
Keep it short and to the point. -12.75. In the year 2008, what is the difference between the Emissions(in percent) of Sweden and Emissions(in percent) of Ukraine?
Keep it short and to the point. -35.04. In the year 2008, what is the difference between the Emissions(in percent) in Tanzania and Emissions(in percent) in Ukraine?
Offer a very short reply. -22.29. In the year 2009, what is the difference between the Emissions(in percent) of China and Emissions(in percent) of Sweden?
Offer a very short reply. -3.56. In the year 2009, what is the difference between the Emissions(in percent) in China and Emissions(in percent) in Tanzania?
Make the answer very short. -17.94. In the year 2009, what is the difference between the Emissions(in percent) of China and Emissions(in percent) of Ukraine?
Ensure brevity in your answer.  -33.8. In the year 2009, what is the difference between the Emissions(in percent) in Sweden and Emissions(in percent) in Tanzania?
Your answer should be compact. -14.38. In the year 2009, what is the difference between the Emissions(in percent) of Sweden and Emissions(in percent) of Ukraine?
Make the answer very short. -30.24. In the year 2009, what is the difference between the Emissions(in percent) of Tanzania and Emissions(in percent) of Ukraine?
Offer a terse response. -15.86. In the year 2010, what is the difference between the Emissions(in percent) in China and Emissions(in percent) in Sweden?
Offer a terse response. -4. In the year 2010, what is the difference between the Emissions(in percent) in China and Emissions(in percent) in Tanzania?
Ensure brevity in your answer.  -19.14. In the year 2010, what is the difference between the Emissions(in percent) of China and Emissions(in percent) of Ukraine?
Offer a very short reply. -39.17. In the year 2010, what is the difference between the Emissions(in percent) in Sweden and Emissions(in percent) in Tanzania?
Your answer should be very brief. -15.13. In the year 2010, what is the difference between the Emissions(in percent) of Sweden and Emissions(in percent) of Ukraine?
Keep it short and to the point. -35.17. In the year 2010, what is the difference between the Emissions(in percent) in Tanzania and Emissions(in percent) in Ukraine?
Make the answer very short. -20.04. What is the ratio of the Emissions(in percent) of China in 2004 to that in 2005?
Provide a short and direct response. 0.92. What is the ratio of the Emissions(in percent) of Sweden in 2004 to that in 2005?
Your answer should be compact. 0.99. What is the ratio of the Emissions(in percent) in Tanzania in 2004 to that in 2005?
Provide a short and direct response. 0.46. What is the ratio of the Emissions(in percent) of Ukraine in 2004 to that in 2005?
Keep it short and to the point. 0.98. What is the ratio of the Emissions(in percent) in China in 2004 to that in 2006?
Your answer should be compact. 0.84. What is the ratio of the Emissions(in percent) in Sweden in 2004 to that in 2006?
Offer a very short reply. 0.91. What is the ratio of the Emissions(in percent) of Tanzania in 2004 to that in 2006?
Give a very brief answer. 0.36. What is the ratio of the Emissions(in percent) of Ukraine in 2004 to that in 2006?
Offer a very short reply. 1.11. What is the ratio of the Emissions(in percent) of China in 2004 to that in 2007?
Give a very brief answer. 0.71. What is the ratio of the Emissions(in percent) of Sweden in 2004 to that in 2007?
Give a very brief answer. 0.86. What is the ratio of the Emissions(in percent) of Tanzania in 2004 to that in 2007?
Provide a succinct answer. 0.33. What is the ratio of the Emissions(in percent) of Ukraine in 2004 to that in 2007?
Your response must be concise. 1.13. What is the ratio of the Emissions(in percent) in China in 2004 to that in 2008?
Offer a terse response. 0.64. What is the ratio of the Emissions(in percent) of Sweden in 2004 to that in 2008?
Offer a terse response. 0.96. What is the ratio of the Emissions(in percent) in Tanzania in 2004 to that in 2008?
Provide a short and direct response. 0.34. What is the ratio of the Emissions(in percent) in Ukraine in 2004 to that in 2008?
Provide a succinct answer. 1.14. What is the ratio of the Emissions(in percent) in China in 2004 to that in 2009?
Your answer should be very brief. 0.63. What is the ratio of the Emissions(in percent) in Sweden in 2004 to that in 2009?
Ensure brevity in your answer.  0.65. What is the ratio of the Emissions(in percent) in Tanzania in 2004 to that in 2009?
Your answer should be compact. 0.28. What is the ratio of the Emissions(in percent) in Ukraine in 2004 to that in 2009?
Make the answer very short. 1.23. What is the ratio of the Emissions(in percent) in China in 2004 to that in 2010?
Your response must be concise. 0.57. What is the ratio of the Emissions(in percent) in Sweden in 2004 to that in 2010?
Your response must be concise. 0.58. What is the ratio of the Emissions(in percent) of Tanzania in 2004 to that in 2010?
Provide a short and direct response. 0.26. What is the ratio of the Emissions(in percent) of Ukraine in 2004 to that in 2010?
Your answer should be compact. 1.06. What is the ratio of the Emissions(in percent) of China in 2005 to that in 2006?
Your response must be concise. 0.91. What is the ratio of the Emissions(in percent) of Sweden in 2005 to that in 2006?
Your answer should be compact. 0.92. What is the ratio of the Emissions(in percent) of Tanzania in 2005 to that in 2006?
Your response must be concise. 0.79. What is the ratio of the Emissions(in percent) of Ukraine in 2005 to that in 2006?
Provide a short and direct response. 1.13. What is the ratio of the Emissions(in percent) of China in 2005 to that in 2007?
Make the answer very short. 0.77. What is the ratio of the Emissions(in percent) of Sweden in 2005 to that in 2007?
Keep it short and to the point. 0.86. What is the ratio of the Emissions(in percent) in Tanzania in 2005 to that in 2007?
Your answer should be compact. 0.72. What is the ratio of the Emissions(in percent) of Ukraine in 2005 to that in 2007?
Provide a short and direct response. 1.15. What is the ratio of the Emissions(in percent) in China in 2005 to that in 2008?
Your answer should be compact. 0.69. What is the ratio of the Emissions(in percent) in Sweden in 2005 to that in 2008?
Your answer should be very brief. 0.97. What is the ratio of the Emissions(in percent) in Tanzania in 2005 to that in 2008?
Provide a succinct answer. 0.74. What is the ratio of the Emissions(in percent) of Ukraine in 2005 to that in 2008?
Ensure brevity in your answer.  1.15. What is the ratio of the Emissions(in percent) of China in 2005 to that in 2009?
Provide a short and direct response. 0.69. What is the ratio of the Emissions(in percent) in Sweden in 2005 to that in 2009?
Your answer should be compact. 0.66. What is the ratio of the Emissions(in percent) in Tanzania in 2005 to that in 2009?
Provide a short and direct response. 0.61. What is the ratio of the Emissions(in percent) in Ukraine in 2005 to that in 2009?
Give a very brief answer. 1.25. What is the ratio of the Emissions(in percent) in China in 2005 to that in 2010?
Ensure brevity in your answer.  0.62. What is the ratio of the Emissions(in percent) of Sweden in 2005 to that in 2010?
Keep it short and to the point. 0.59. What is the ratio of the Emissions(in percent) in Tanzania in 2005 to that in 2010?
Give a very brief answer. 0.57. What is the ratio of the Emissions(in percent) in Ukraine in 2005 to that in 2010?
Your answer should be very brief. 1.08. What is the ratio of the Emissions(in percent) in China in 2006 to that in 2007?
Ensure brevity in your answer.  0.85. What is the ratio of the Emissions(in percent) in Sweden in 2006 to that in 2007?
Your answer should be very brief. 0.94. What is the ratio of the Emissions(in percent) in Tanzania in 2006 to that in 2007?
Offer a terse response. 0.92. What is the ratio of the Emissions(in percent) of Ukraine in 2006 to that in 2007?
Offer a terse response. 1.02. What is the ratio of the Emissions(in percent) of China in 2006 to that in 2008?
Provide a short and direct response. 0.76. What is the ratio of the Emissions(in percent) of Sweden in 2006 to that in 2008?
Offer a terse response. 1.06. What is the ratio of the Emissions(in percent) in Tanzania in 2006 to that in 2008?
Your response must be concise. 0.95. What is the ratio of the Emissions(in percent) of Ukraine in 2006 to that in 2008?
Give a very brief answer. 1.02. What is the ratio of the Emissions(in percent) in China in 2006 to that in 2009?
Offer a terse response. 0.76. What is the ratio of the Emissions(in percent) in Sweden in 2006 to that in 2009?
Ensure brevity in your answer.  0.71. What is the ratio of the Emissions(in percent) of Tanzania in 2006 to that in 2009?
Your answer should be very brief. 0.78. What is the ratio of the Emissions(in percent) of Ukraine in 2006 to that in 2009?
Keep it short and to the point. 1.11. What is the ratio of the Emissions(in percent) in China in 2006 to that in 2010?
Give a very brief answer. 0.68. What is the ratio of the Emissions(in percent) of Sweden in 2006 to that in 2010?
Make the answer very short. 0.64. What is the ratio of the Emissions(in percent) of Tanzania in 2006 to that in 2010?
Provide a succinct answer. 0.73. What is the ratio of the Emissions(in percent) of Ukraine in 2006 to that in 2010?
Offer a terse response. 0.96. What is the ratio of the Emissions(in percent) of China in 2007 to that in 2008?
Offer a very short reply. 0.9. What is the ratio of the Emissions(in percent) of Sweden in 2007 to that in 2008?
Your response must be concise. 1.13. What is the ratio of the Emissions(in percent) in Tanzania in 2007 to that in 2008?
Offer a very short reply. 1.03. What is the ratio of the Emissions(in percent) of China in 2007 to that in 2009?
Provide a succinct answer. 0.89. What is the ratio of the Emissions(in percent) of Sweden in 2007 to that in 2009?
Provide a succinct answer. 0.76. What is the ratio of the Emissions(in percent) of Tanzania in 2007 to that in 2009?
Make the answer very short. 0.85. What is the ratio of the Emissions(in percent) in Ukraine in 2007 to that in 2009?
Make the answer very short. 1.09. What is the ratio of the Emissions(in percent) in China in 2007 to that in 2010?
Make the answer very short. 0.8. What is the ratio of the Emissions(in percent) in Sweden in 2007 to that in 2010?
Provide a short and direct response. 0.68. What is the ratio of the Emissions(in percent) in Tanzania in 2007 to that in 2010?
Provide a short and direct response. 0.79. What is the ratio of the Emissions(in percent) in Ukraine in 2007 to that in 2010?
Keep it short and to the point. 0.94. What is the ratio of the Emissions(in percent) in China in 2008 to that in 2009?
Offer a very short reply. 1. What is the ratio of the Emissions(in percent) of Sweden in 2008 to that in 2009?
Your answer should be very brief. 0.68. What is the ratio of the Emissions(in percent) of Tanzania in 2008 to that in 2009?
Ensure brevity in your answer.  0.83. What is the ratio of the Emissions(in percent) in Ukraine in 2008 to that in 2009?
Give a very brief answer. 1.08. What is the ratio of the Emissions(in percent) of China in 2008 to that in 2010?
Your answer should be compact. 0.89. What is the ratio of the Emissions(in percent) in Sweden in 2008 to that in 2010?
Your answer should be compact. 0.6. What is the ratio of the Emissions(in percent) of Tanzania in 2008 to that in 2010?
Provide a succinct answer. 0.77. What is the ratio of the Emissions(in percent) of Ukraine in 2008 to that in 2010?
Your answer should be very brief. 0.94. What is the ratio of the Emissions(in percent) of China in 2009 to that in 2010?
Provide a short and direct response. 0.9. What is the ratio of the Emissions(in percent) in Sweden in 2009 to that in 2010?
Offer a terse response. 0.89. What is the ratio of the Emissions(in percent) in Tanzania in 2009 to that in 2010?
Ensure brevity in your answer.  0.93. What is the ratio of the Emissions(in percent) of Ukraine in 2009 to that in 2010?
Your answer should be very brief. 0.86. What is the difference between the highest and the second highest Emissions(in percent) of China?
Give a very brief answer. 0.24. What is the difference between the highest and the second highest Emissions(in percent) of Sweden?
Provide a succinct answer. 0.69. What is the difference between the highest and the second highest Emissions(in percent) in Tanzania?
Offer a terse response. 1.44. What is the difference between the highest and the second highest Emissions(in percent) in Ukraine?
Your response must be concise. 0.7. What is the difference between the highest and the lowest Emissions(in percent) of China?
Your response must be concise. 1.03. What is the difference between the highest and the lowest Emissions(in percent) in Sweden?
Provide a succinct answer. 2.68. What is the difference between the highest and the lowest Emissions(in percent) in Tanzania?
Make the answer very short. 15.89. What is the difference between the highest and the lowest Emissions(in percent) of Ukraine?
Your response must be concise. 8.93. 